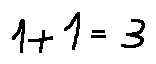<formula> <loc_0><loc_0><loc_500><loc_500>1 + 1 = 3</formula> 